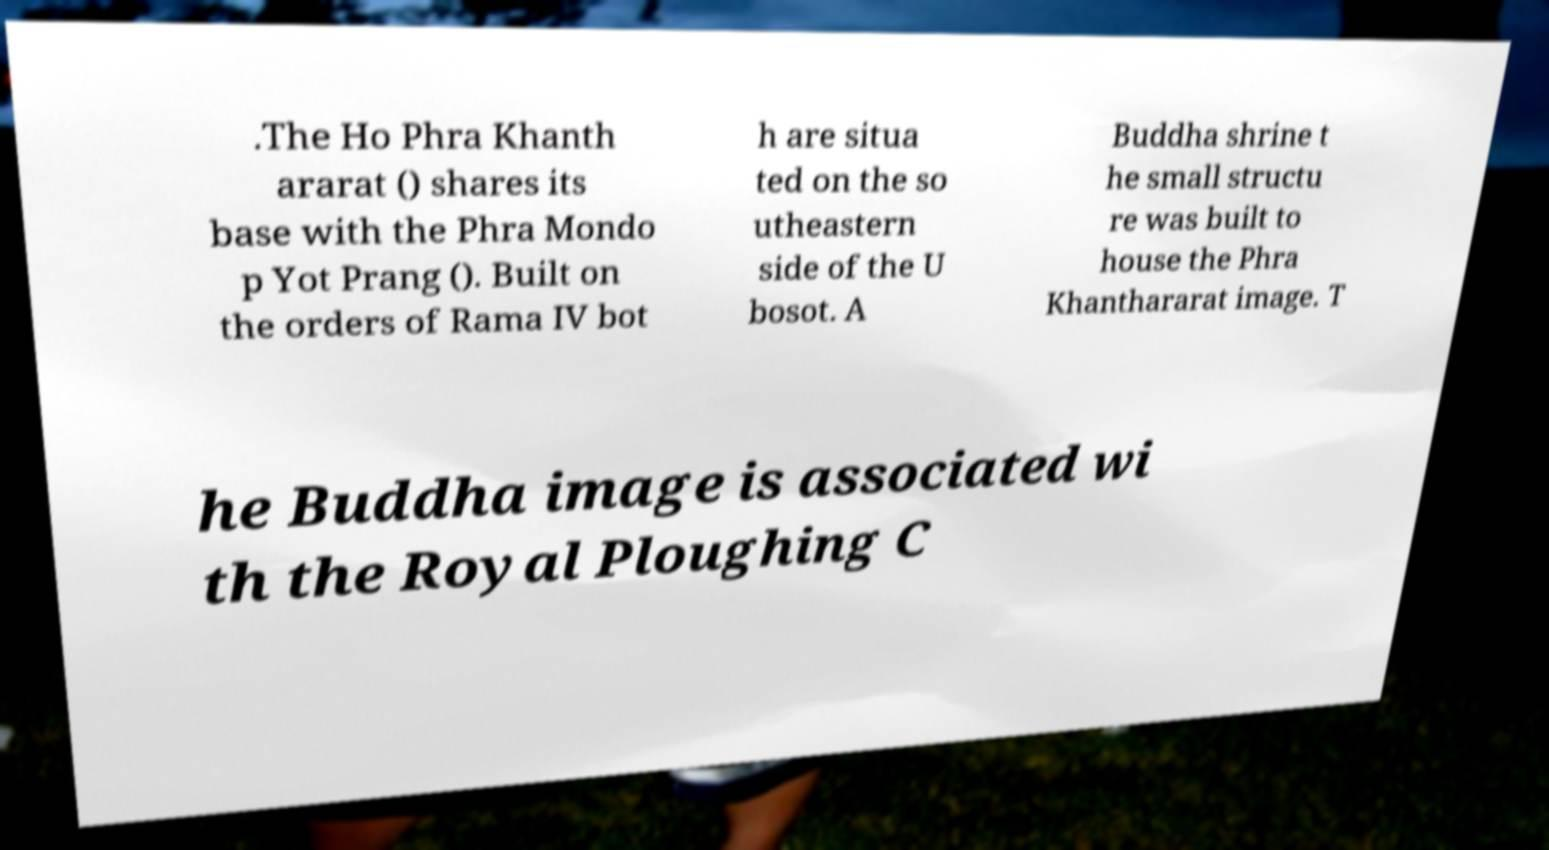I need the written content from this picture converted into text. Can you do that? .The Ho Phra Khanth ararat () shares its base with the Phra Mondo p Yot Prang (). Built on the orders of Rama IV bot h are situa ted on the so utheastern side of the U bosot. A Buddha shrine t he small structu re was built to house the Phra Khanthararat image. T he Buddha image is associated wi th the Royal Ploughing C 